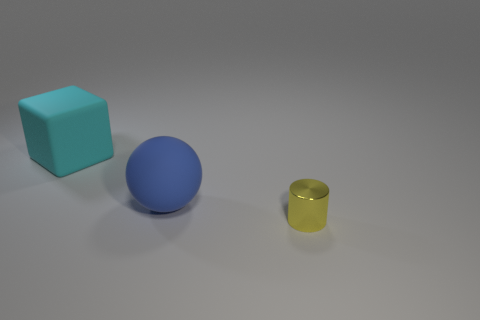How big is the matte thing that is left of the blue rubber ball?
Provide a short and direct response. Large. Is the number of big cyan matte spheres less than the number of tiny yellow objects?
Offer a very short reply. Yes. Are there any cylinders that have the same color as the tiny thing?
Provide a succinct answer. No. What shape is the object that is on the right side of the large cyan thing and behind the shiny cylinder?
Make the answer very short. Sphere. The large object on the left side of the big object in front of the big cyan thing is what shape?
Your answer should be compact. Cube. Is the shape of the cyan thing the same as the blue object?
Provide a succinct answer. No. Is the color of the metal cylinder the same as the large cube?
Give a very brief answer. No. There is a object behind the large thing that is in front of the big rubber cube; what number of objects are right of it?
Keep it short and to the point. 2. What shape is the thing that is the same material as the big sphere?
Offer a terse response. Cube. What material is the big thing that is in front of the big object that is left of the big object that is in front of the matte block made of?
Offer a very short reply. Rubber. 